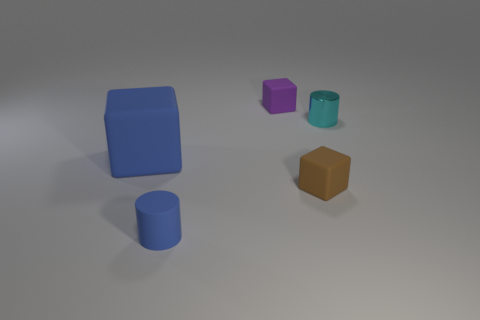Is there anything else that has the same size as the blue block?
Your answer should be compact. No. Are the tiny blue cylinder and the tiny block that is behind the small cyan shiny thing made of the same material?
Provide a short and direct response. Yes. What material is the big blue object?
Provide a short and direct response. Rubber. There is a big block that is the same color as the small matte cylinder; what is its material?
Keep it short and to the point. Rubber. How many other things are there of the same material as the blue cube?
Keep it short and to the point. 3. There is a object that is both in front of the large rubber object and behind the blue matte cylinder; what shape is it?
Keep it short and to the point. Cube. There is a tiny cylinder that is the same material as the purple thing; what is its color?
Keep it short and to the point. Blue. Is the number of large rubber blocks to the right of the small cyan metal object the same as the number of cyan objects?
Keep it short and to the point. No. What is the shape of the purple object that is the same size as the brown object?
Make the answer very short. Cube. What number of other things are there of the same shape as the brown object?
Provide a short and direct response. 2. 